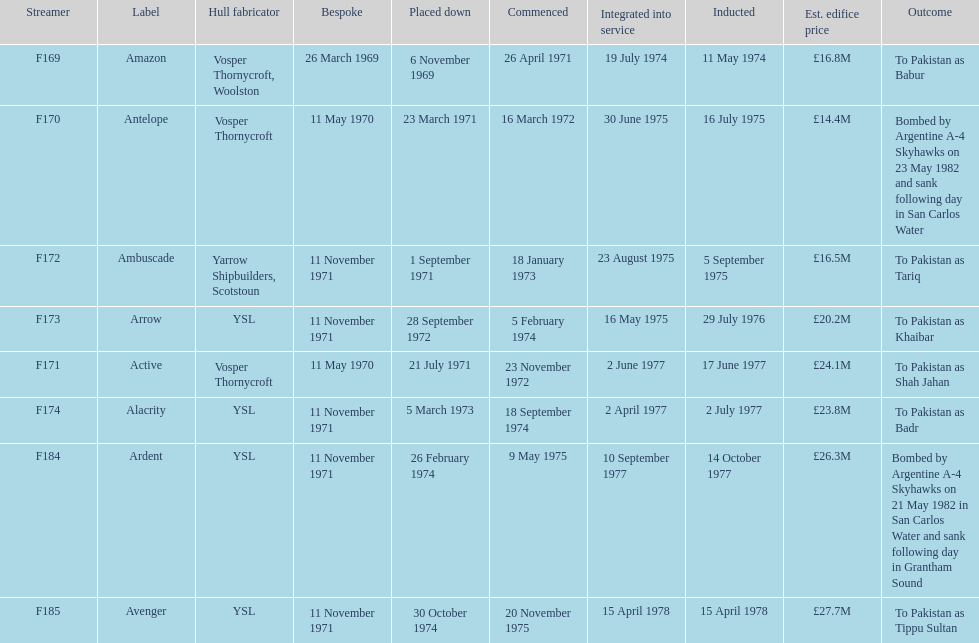Which ships cost more than ps25.0m to build? Ardent, Avenger. Of the ships listed in the answer above, which one cost the most to build? Avenger. 